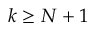<formula> <loc_0><loc_0><loc_500><loc_500>k \geq N + 1</formula> 